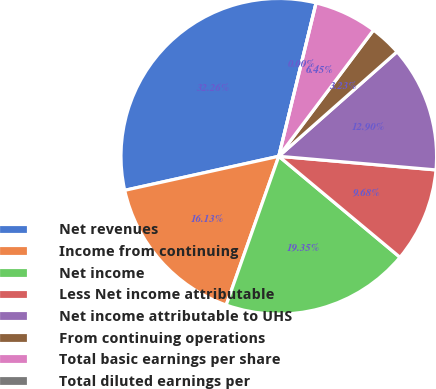Convert chart to OTSL. <chart><loc_0><loc_0><loc_500><loc_500><pie_chart><fcel>Net revenues<fcel>Income from continuing<fcel>Net income<fcel>Less Net income attributable<fcel>Net income attributable to UHS<fcel>From continuing operations<fcel>Total basic earnings per share<fcel>Total diluted earnings per<nl><fcel>32.26%<fcel>16.13%<fcel>19.35%<fcel>9.68%<fcel>12.9%<fcel>3.23%<fcel>6.45%<fcel>0.0%<nl></chart> 